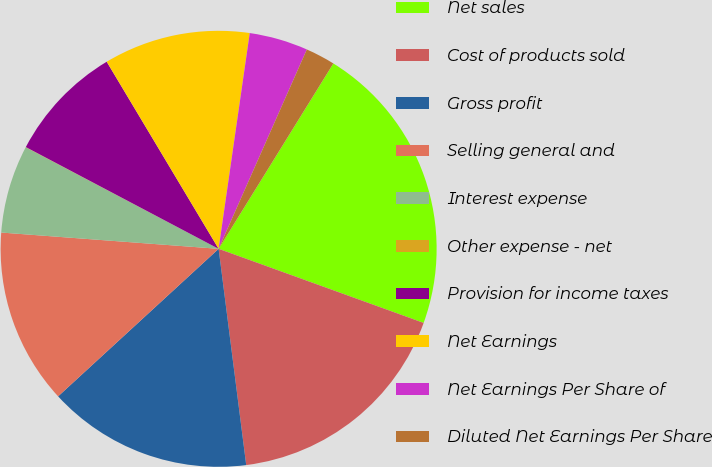Convert chart. <chart><loc_0><loc_0><loc_500><loc_500><pie_chart><fcel>Net sales<fcel>Cost of products sold<fcel>Gross profit<fcel>Selling general and<fcel>Interest expense<fcel>Other expense - net<fcel>Provision for income taxes<fcel>Net Earnings<fcel>Net Earnings Per Share of<fcel>Diluted Net Earnings Per Share<nl><fcel>21.7%<fcel>17.46%<fcel>15.19%<fcel>13.02%<fcel>6.52%<fcel>0.02%<fcel>8.69%<fcel>10.86%<fcel>4.35%<fcel>2.19%<nl></chart> 